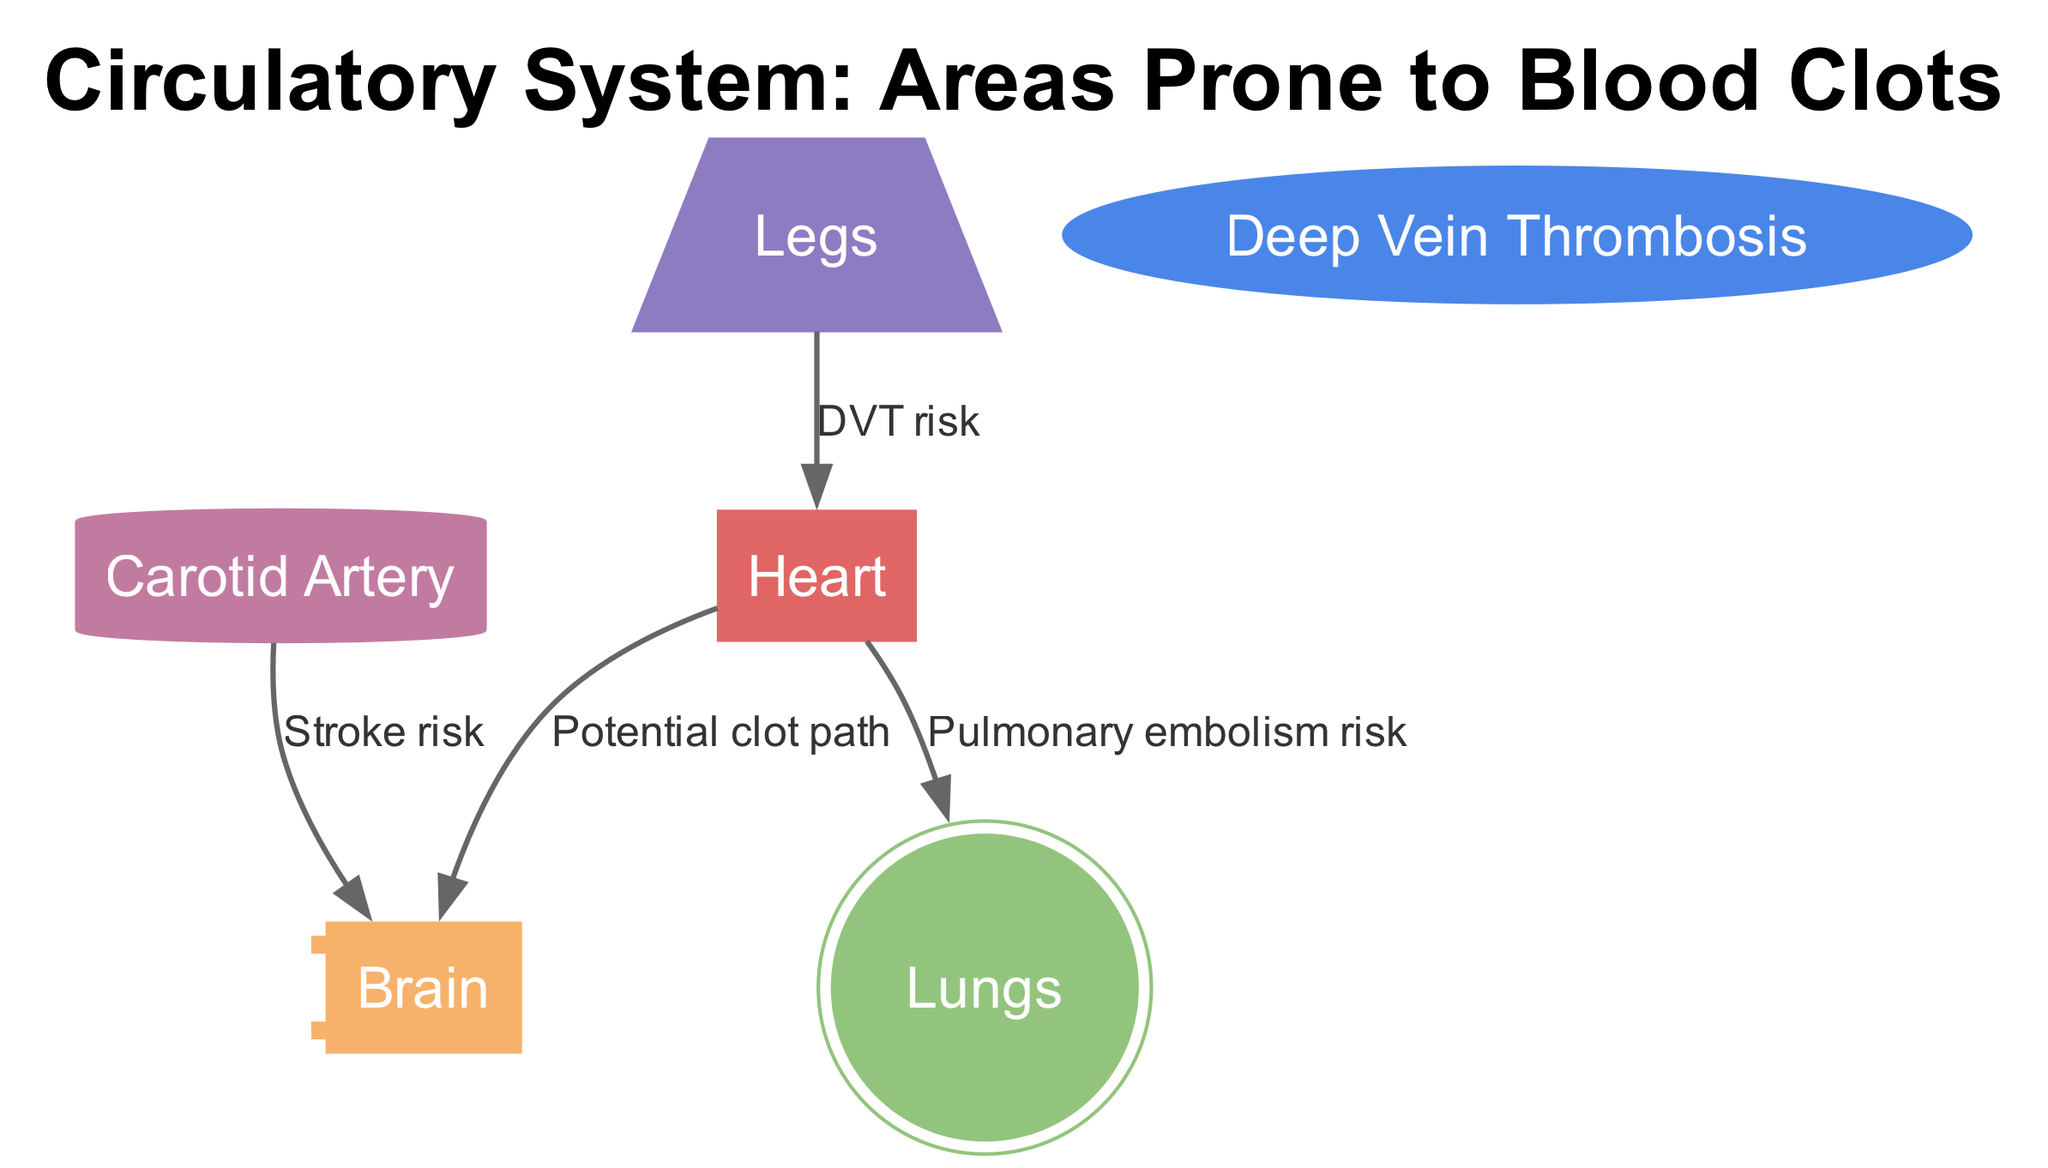What is the primary organ in the circulatory system? The diagram shows "Heart" as one of the nodes, indicating its central role in the circulatory system.
Answer: Heart How many nodes are present in the diagram? The diagram includes a total of six nodes: Heart, Brain, Legs, Lungs, Carotid Artery, and Deep Vein Thrombosis. Counting these gives us six.
Answer: 6 What is the relationship between the heart and the brain? The diagram shows an edge labeled "Potential clot path" connecting the heart to the brain, indicating that blood clots can potentially travel from the heart to the brain.
Answer: Potential clot path Which area is associated with Deep Vein Thrombosis risk? The diagram indicates an edge from "Legs" to "Heart" labeled "DVT risk", suggesting that Deep Vein Thrombosis primarily involves the legs.
Answer: Legs What is the risk associated with the carotid artery? The edge from "Carotid Artery" to "Brain" is labeled "Stroke risk", indicating that blood clots from this artery can lead to strokes.
Answer: Stroke risk What is a possible consequence of a clot traveling from the heart to the lungs? The diagram has an edge connecting the heart to the lungs labeled "Pulmonary embolism risk", which means a clot traveling from the heart could cause a pulmonary embolism.
Answer: Pulmonary embolism risk Identify a potential source area for clots that can affect the brain. The diagram shows an edge labeled "Stroke risk" from "Carotid Artery" to "Brain", indicating that clots can originate in this artery to impact the brain.
Answer: Carotid Artery Which node indicates an area where blood clots can form in the legs? The node "Legs" represents the area where deep vein thrombosis can occur, making it a source for clots related to leg issues.
Answer: Legs How many edges connect the heart to other areas? The diagram illustrates three edges stemming from the heart to other nodes: one to the brain, one to the lungs, and one to the legs, confirming three connections.
Answer: 3 